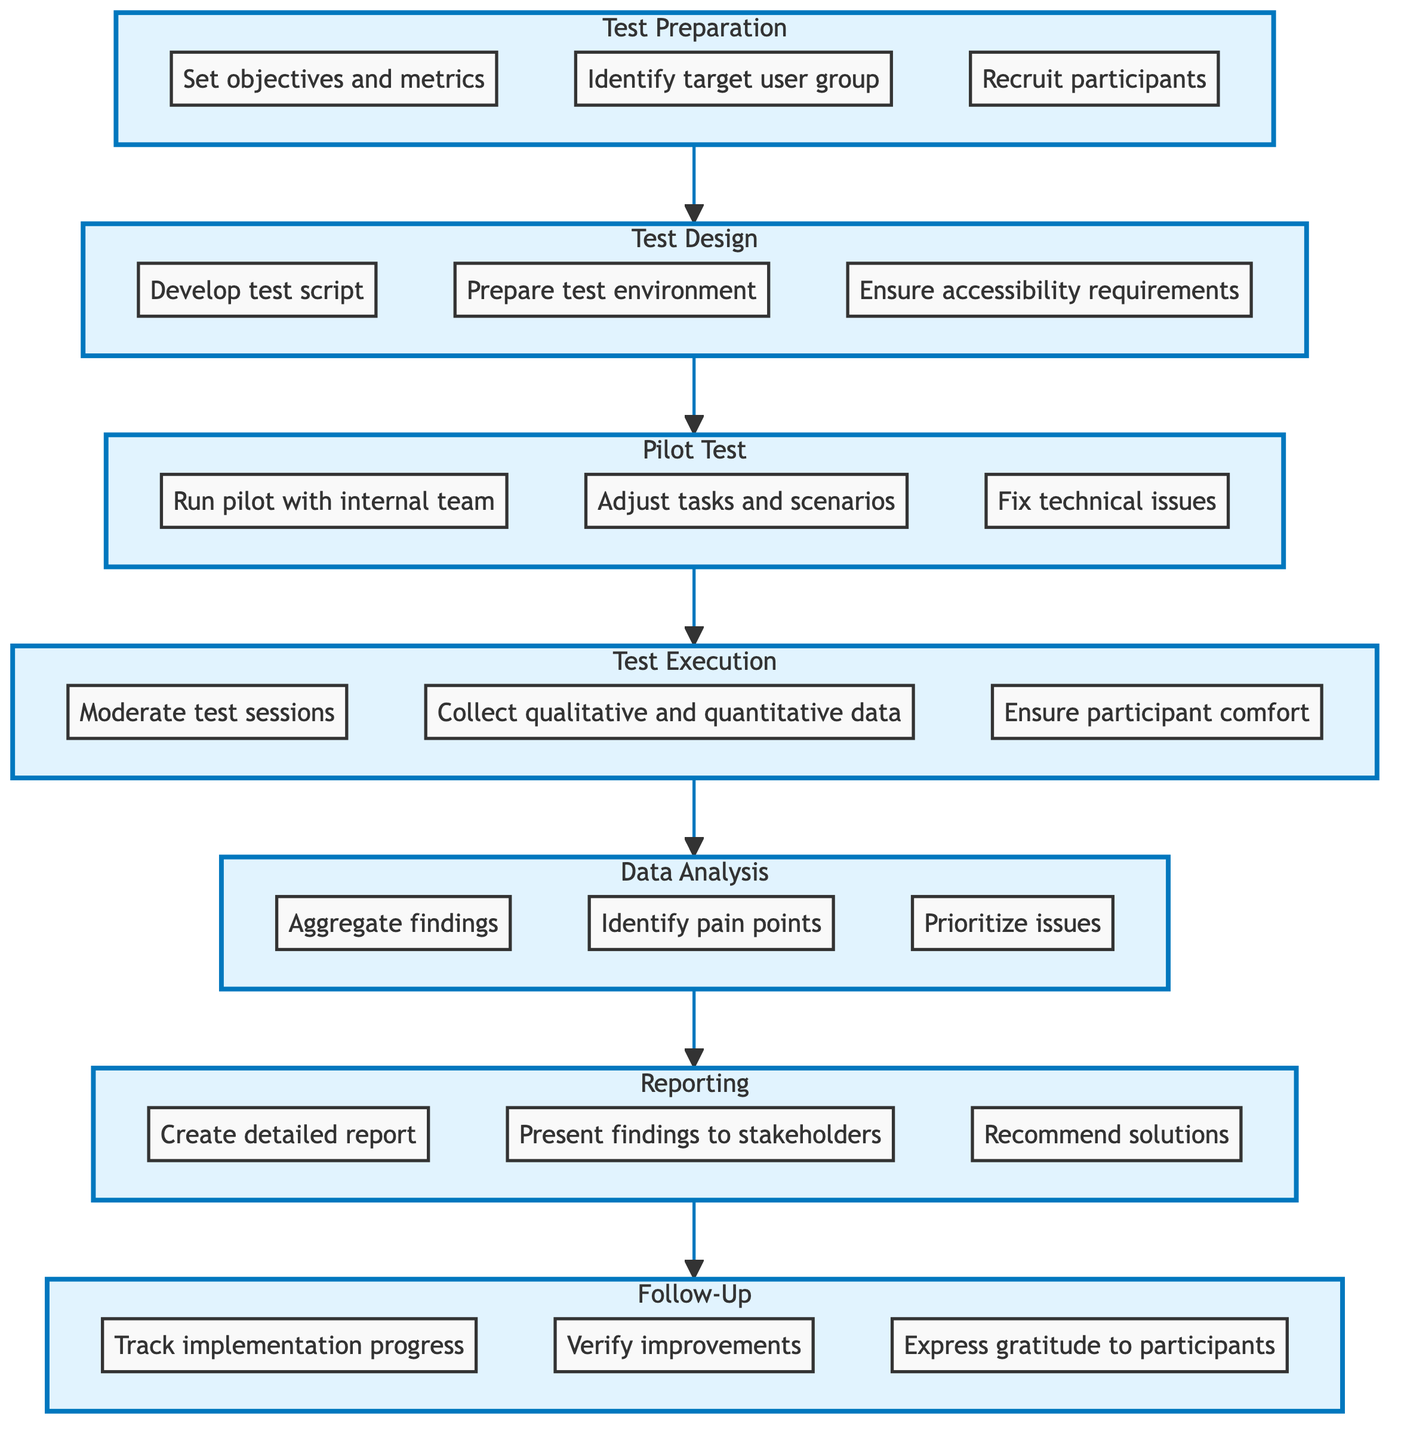What is the first step in the usability test session lifecycle? The first step is represented by the bottommost node labeled "Test Preparation". This indicates that it is the starting point in the process of conducting usability tests.
Answer: Test Preparation How many main steps are there in the usability test session lifecycle? Counting the nodes from the diagram, there are seven main steps, starting from "Test Preparation" and ending at "Follow-Up".
Answer: Seven What follows after the "Pilot Test" step? The diagram shows that "Test Execution" directly follows "Pilot Test", as indicated by the arrow connecting the two nodes.
Answer: Test Execution Which step involves moderating test sessions? "Test Execution" is the step that involves moderating test sessions, as it is detailed under the tasks associated with that node.
Answer: Test Execution What is the last step in the usability test session lifecycle? The final node at the top of the diagram is "Follow-Up", demonstrating that it is the concluding phase in the usability test lifecycle.
Answer: Follow-Up Which step focuses on analyzing collected data? The "Data Analysis" step is specifically about analyzing the collected data to identify usability issues. This step comes after "Test Execution" in the flow.
Answer: Data Analysis How does the "Reporting" phase relate to "Data Analysis"? "Reporting" occurs after "Data Analysis", suggesting that it is dependent on the findings from the analysis stage that precedes it in the lifecycle.
Answer: Reporting What is the purpose of the "Pilot Test"? The purpose of the "Pilot Test" is to conduct a preliminary test to check for issues, which includes running a pilot with the internal team and adjusting scenarios based on findings.
Answer: Check for issues Which step involves recruiting participants? Recruiting participants is specifically mentioned under the "Test Preparation" step, highlighting its importance in the initial phase of preparing for usability tests.
Answer: Test Preparation What action is recommended after data is analyzed? The recommended action after data analysis is to create a detailed report in the "Reporting" step, highlighting the findings and potential solutions.
Answer: Create detailed report 